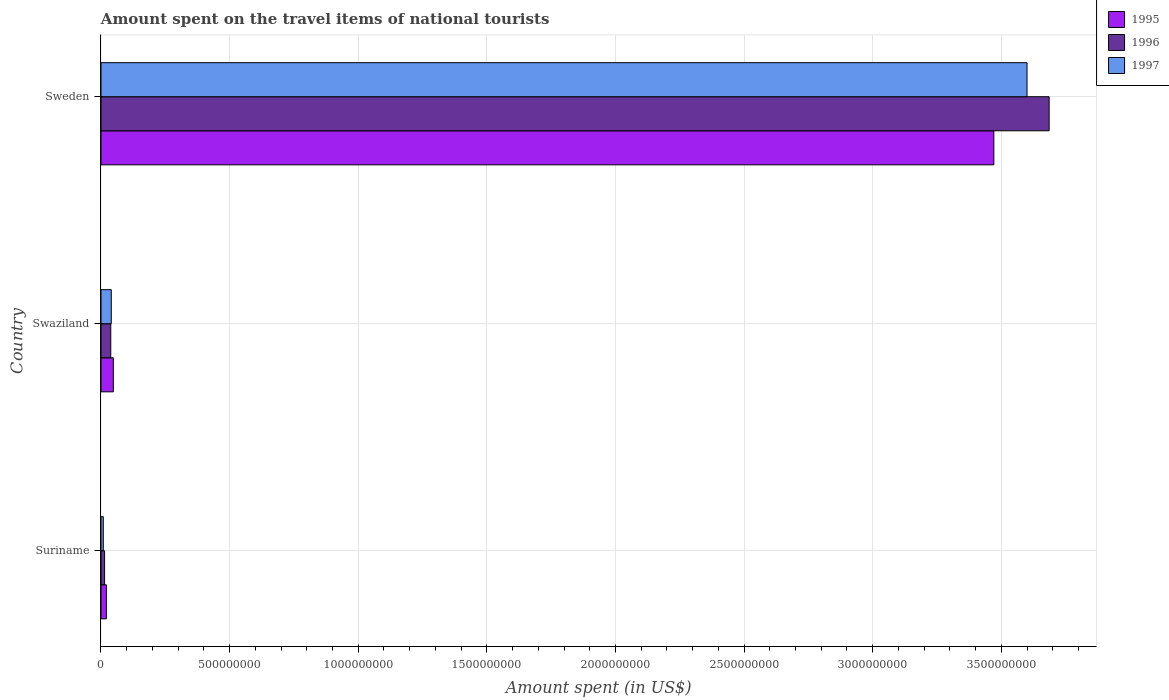How many groups of bars are there?
Provide a short and direct response. 3. Are the number of bars on each tick of the Y-axis equal?
Offer a terse response. Yes. How many bars are there on the 1st tick from the bottom?
Offer a very short reply. 3. What is the label of the 3rd group of bars from the top?
Your answer should be very brief. Suriname. In how many cases, is the number of bars for a given country not equal to the number of legend labels?
Your answer should be very brief. 0. What is the amount spent on the travel items of national tourists in 1996 in Suriname?
Ensure brevity in your answer.  1.40e+07. Across all countries, what is the maximum amount spent on the travel items of national tourists in 1996?
Keep it short and to the point. 3.69e+09. Across all countries, what is the minimum amount spent on the travel items of national tourists in 1996?
Make the answer very short. 1.40e+07. In which country was the amount spent on the travel items of national tourists in 1995 minimum?
Provide a succinct answer. Suriname. What is the total amount spent on the travel items of national tourists in 1995 in the graph?
Your response must be concise. 3.54e+09. What is the difference between the amount spent on the travel items of national tourists in 1997 in Suriname and that in Swaziland?
Make the answer very short. -3.10e+07. What is the difference between the amount spent on the travel items of national tourists in 1996 in Suriname and the amount spent on the travel items of national tourists in 1997 in Swaziland?
Your answer should be very brief. -2.60e+07. What is the average amount spent on the travel items of national tourists in 1997 per country?
Offer a very short reply. 1.22e+09. What is the difference between the amount spent on the travel items of national tourists in 1997 and amount spent on the travel items of national tourists in 1995 in Suriname?
Provide a short and direct response. -1.20e+07. In how many countries, is the amount spent on the travel items of national tourists in 1995 greater than 600000000 US$?
Your answer should be compact. 1. What is the ratio of the amount spent on the travel items of national tourists in 1995 in Swaziland to that in Sweden?
Make the answer very short. 0.01. Is the difference between the amount spent on the travel items of national tourists in 1997 in Swaziland and Sweden greater than the difference between the amount spent on the travel items of national tourists in 1995 in Swaziland and Sweden?
Offer a very short reply. No. What is the difference between the highest and the second highest amount spent on the travel items of national tourists in 1996?
Your answer should be compact. 3.65e+09. What is the difference between the highest and the lowest amount spent on the travel items of national tourists in 1996?
Give a very brief answer. 3.67e+09. What does the 1st bar from the top in Suriname represents?
Your answer should be very brief. 1997. Is it the case that in every country, the sum of the amount spent on the travel items of national tourists in 1997 and amount spent on the travel items of national tourists in 1995 is greater than the amount spent on the travel items of national tourists in 1996?
Your response must be concise. Yes. How many bars are there?
Keep it short and to the point. 9. What is the difference between two consecutive major ticks on the X-axis?
Offer a terse response. 5.00e+08. Does the graph contain any zero values?
Your response must be concise. No. How many legend labels are there?
Your answer should be very brief. 3. What is the title of the graph?
Offer a terse response. Amount spent on the travel items of national tourists. Does "2008" appear as one of the legend labels in the graph?
Your answer should be very brief. No. What is the label or title of the X-axis?
Your response must be concise. Amount spent (in US$). What is the Amount spent (in US$) in 1995 in Suriname?
Your answer should be very brief. 2.10e+07. What is the Amount spent (in US$) in 1996 in Suriname?
Provide a succinct answer. 1.40e+07. What is the Amount spent (in US$) of 1997 in Suriname?
Offer a very short reply. 9.00e+06. What is the Amount spent (in US$) of 1995 in Swaziland?
Make the answer very short. 4.80e+07. What is the Amount spent (in US$) of 1996 in Swaziland?
Give a very brief answer. 3.80e+07. What is the Amount spent (in US$) in 1997 in Swaziland?
Your answer should be very brief. 4.00e+07. What is the Amount spent (in US$) of 1995 in Sweden?
Your response must be concise. 3.47e+09. What is the Amount spent (in US$) of 1996 in Sweden?
Keep it short and to the point. 3.69e+09. What is the Amount spent (in US$) of 1997 in Sweden?
Keep it short and to the point. 3.60e+09. Across all countries, what is the maximum Amount spent (in US$) in 1995?
Your answer should be compact. 3.47e+09. Across all countries, what is the maximum Amount spent (in US$) of 1996?
Your answer should be very brief. 3.69e+09. Across all countries, what is the maximum Amount spent (in US$) of 1997?
Keep it short and to the point. 3.60e+09. Across all countries, what is the minimum Amount spent (in US$) of 1995?
Your answer should be very brief. 2.10e+07. Across all countries, what is the minimum Amount spent (in US$) in 1996?
Your answer should be very brief. 1.40e+07. Across all countries, what is the minimum Amount spent (in US$) of 1997?
Ensure brevity in your answer.  9.00e+06. What is the total Amount spent (in US$) in 1995 in the graph?
Provide a short and direct response. 3.54e+09. What is the total Amount spent (in US$) in 1996 in the graph?
Your answer should be compact. 3.74e+09. What is the total Amount spent (in US$) of 1997 in the graph?
Ensure brevity in your answer.  3.65e+09. What is the difference between the Amount spent (in US$) in 1995 in Suriname and that in Swaziland?
Keep it short and to the point. -2.70e+07. What is the difference between the Amount spent (in US$) of 1996 in Suriname and that in Swaziland?
Ensure brevity in your answer.  -2.40e+07. What is the difference between the Amount spent (in US$) of 1997 in Suriname and that in Swaziland?
Provide a succinct answer. -3.10e+07. What is the difference between the Amount spent (in US$) of 1995 in Suriname and that in Sweden?
Your answer should be very brief. -3.45e+09. What is the difference between the Amount spent (in US$) in 1996 in Suriname and that in Sweden?
Keep it short and to the point. -3.67e+09. What is the difference between the Amount spent (in US$) of 1997 in Suriname and that in Sweden?
Ensure brevity in your answer.  -3.59e+09. What is the difference between the Amount spent (in US$) of 1995 in Swaziland and that in Sweden?
Your answer should be very brief. -3.42e+09. What is the difference between the Amount spent (in US$) of 1996 in Swaziland and that in Sweden?
Offer a terse response. -3.65e+09. What is the difference between the Amount spent (in US$) in 1997 in Swaziland and that in Sweden?
Your answer should be compact. -3.56e+09. What is the difference between the Amount spent (in US$) of 1995 in Suriname and the Amount spent (in US$) of 1996 in Swaziland?
Keep it short and to the point. -1.70e+07. What is the difference between the Amount spent (in US$) in 1995 in Suriname and the Amount spent (in US$) in 1997 in Swaziland?
Keep it short and to the point. -1.90e+07. What is the difference between the Amount spent (in US$) of 1996 in Suriname and the Amount spent (in US$) of 1997 in Swaziland?
Your answer should be very brief. -2.60e+07. What is the difference between the Amount spent (in US$) of 1995 in Suriname and the Amount spent (in US$) of 1996 in Sweden?
Your answer should be very brief. -3.66e+09. What is the difference between the Amount spent (in US$) in 1995 in Suriname and the Amount spent (in US$) in 1997 in Sweden?
Give a very brief answer. -3.58e+09. What is the difference between the Amount spent (in US$) of 1996 in Suriname and the Amount spent (in US$) of 1997 in Sweden?
Give a very brief answer. -3.59e+09. What is the difference between the Amount spent (in US$) in 1995 in Swaziland and the Amount spent (in US$) in 1996 in Sweden?
Keep it short and to the point. -3.64e+09. What is the difference between the Amount spent (in US$) of 1995 in Swaziland and the Amount spent (in US$) of 1997 in Sweden?
Make the answer very short. -3.55e+09. What is the difference between the Amount spent (in US$) of 1996 in Swaziland and the Amount spent (in US$) of 1997 in Sweden?
Your answer should be compact. -3.56e+09. What is the average Amount spent (in US$) of 1995 per country?
Make the answer very short. 1.18e+09. What is the average Amount spent (in US$) of 1996 per country?
Give a very brief answer. 1.25e+09. What is the average Amount spent (in US$) in 1997 per country?
Provide a short and direct response. 1.22e+09. What is the difference between the Amount spent (in US$) in 1995 and Amount spent (in US$) in 1996 in Suriname?
Your answer should be very brief. 7.00e+06. What is the difference between the Amount spent (in US$) of 1996 and Amount spent (in US$) of 1997 in Suriname?
Provide a succinct answer. 5.00e+06. What is the difference between the Amount spent (in US$) of 1995 and Amount spent (in US$) of 1996 in Sweden?
Offer a very short reply. -2.15e+08. What is the difference between the Amount spent (in US$) of 1995 and Amount spent (in US$) of 1997 in Sweden?
Provide a short and direct response. -1.29e+08. What is the difference between the Amount spent (in US$) in 1996 and Amount spent (in US$) in 1997 in Sweden?
Offer a terse response. 8.60e+07. What is the ratio of the Amount spent (in US$) in 1995 in Suriname to that in Swaziland?
Your answer should be compact. 0.44. What is the ratio of the Amount spent (in US$) of 1996 in Suriname to that in Swaziland?
Keep it short and to the point. 0.37. What is the ratio of the Amount spent (in US$) of 1997 in Suriname to that in Swaziland?
Offer a terse response. 0.23. What is the ratio of the Amount spent (in US$) of 1995 in Suriname to that in Sweden?
Offer a terse response. 0.01. What is the ratio of the Amount spent (in US$) of 1996 in Suriname to that in Sweden?
Make the answer very short. 0. What is the ratio of the Amount spent (in US$) of 1997 in Suriname to that in Sweden?
Make the answer very short. 0. What is the ratio of the Amount spent (in US$) of 1995 in Swaziland to that in Sweden?
Offer a very short reply. 0.01. What is the ratio of the Amount spent (in US$) of 1996 in Swaziland to that in Sweden?
Your response must be concise. 0.01. What is the ratio of the Amount spent (in US$) in 1997 in Swaziland to that in Sweden?
Provide a succinct answer. 0.01. What is the difference between the highest and the second highest Amount spent (in US$) of 1995?
Provide a succinct answer. 3.42e+09. What is the difference between the highest and the second highest Amount spent (in US$) in 1996?
Your response must be concise. 3.65e+09. What is the difference between the highest and the second highest Amount spent (in US$) in 1997?
Offer a terse response. 3.56e+09. What is the difference between the highest and the lowest Amount spent (in US$) of 1995?
Keep it short and to the point. 3.45e+09. What is the difference between the highest and the lowest Amount spent (in US$) of 1996?
Keep it short and to the point. 3.67e+09. What is the difference between the highest and the lowest Amount spent (in US$) in 1997?
Offer a very short reply. 3.59e+09. 